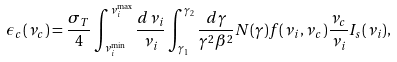<formula> <loc_0><loc_0><loc_500><loc_500>\epsilon _ { c } ( \nu _ { c } ) = \frac { \sigma _ { T } } { 4 } \int _ { \nu _ { i } ^ { \min } } ^ { \nu _ { i } ^ { \max } } \frac { d \nu _ { i } } { \nu _ { i } } \int _ { \gamma _ { 1 } } ^ { \gamma _ { 2 } } \frac { d \gamma } { \gamma ^ { 2 } \beta ^ { 2 } } N ( \gamma ) f ( \nu _ { i } , \nu _ { c } ) \frac { \nu _ { c } } { \nu _ { i } } I _ { s } ( \nu _ { i } ) ,</formula> 